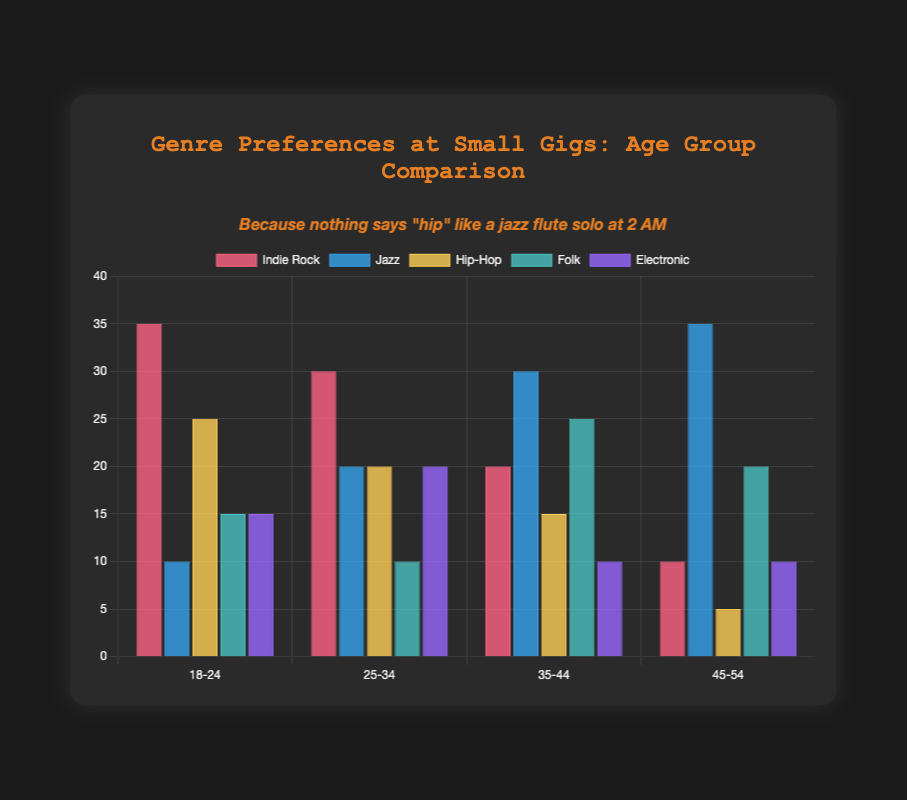What's the most preferred genre for the 18-24 age group? The 18-24 age group has the following preferences: Indie Rock (35), Jazz (10), Hip-Hop (25), Folk (15), Electronic (15). The highest value is for Indie Rock.
Answer: Indie Rock Which age group prefers Jazz the most? Jazz preferences are as follows: 18-24 (10), 25-34 (20), 35-44 (30), 45-54 (35). The 45-54 age group has the highest preference for Jazz.
Answer: 45-54 What's the least liked genre among the 35-44 age group? The preferences for the 35-44 age group are: Indie Rock (20), Jazz (30), Hip-Hop (15), Folk (25), Electronic (10). The lowest value is for Electronic.
Answer: Electronic How many more people in the 18-24 age group prefer Indie Rock compared to Jazz? The preferences for the 18-24 age group are Indie Rock (35) and Jazz (10). The difference is 35 - 10.
Answer: 25 Which genre has the smallest total preference across all age groups? Summing preferences across all age groups: Indie Rock (35+30+20+10), Jazz (10+20+30+35), Hip-Hop (25+20+15+5), Folk (15+10+25+20), Electronic (15+20+10+10). The totals are Indie Rock (95), Jazz (95), Hip-Hop (65), Folk (70), Electronic (55). The smallest total is for Electronic.
Answer: Electronic For the 25-34 age group, how does Folk's preference compare to Hip-Hop? The 25-34 age group preferences: Folk (10) and Hip-Hop (20). Hip-Hop preference is higher.
Answer: Hip-Hop is higher What is the average preference value for Indie Rock across all age groups? Indie Rock values across age groups are: 35, 30, 20, 10. Sum them: 35 + 30 + 20 + 10 = 95. Average is 95 / 4.
Answer: 23.75 Which genre does the 45-54 age group prefer the least? The preferences for the 45-54 age group are: Indie Rock (10), Jazz (35), Hip-Hop (5), Folk (20), Electronic (10). The lowest value is for Hip-Hop.
Answer: Hip-Hop Compare the sum of preferences for Hip-Hop in the 35-44 and 45-54 age groups to that for Jazz in the 18-24 and 25-34 age groups. Which sum is higher? Sum of preferences: Hip-Hop in 35-44 and 45-54 (15 + 5 = 20), Jazz in 18-24 and 25-34 (10 + 20 = 30). Jazz sum is higher.
Answer: Jazz What's the combined preference for Folk and Electronic in the 18-24 age group? Folk preference in 18-24 is 15 and Electronic is 15. Combined: 15 + 15.
Answer: 30 